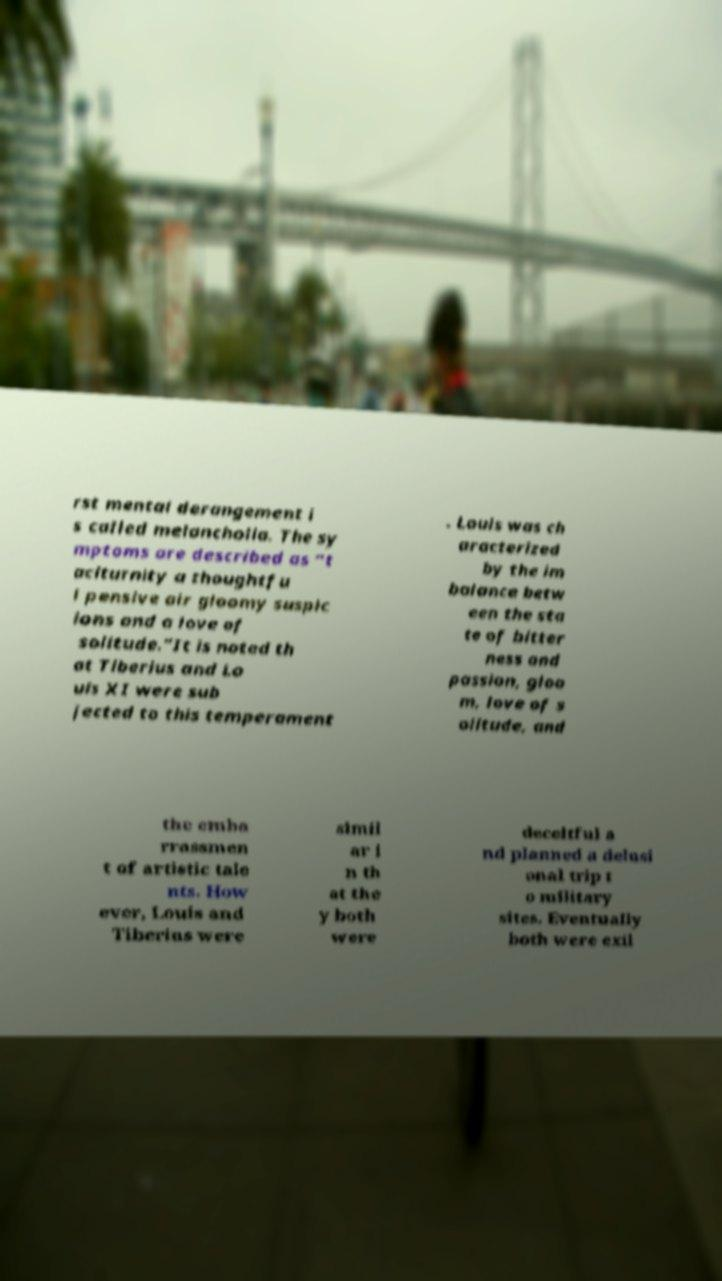Could you extract and type out the text from this image? rst mental derangement i s called melancholia. The sy mptoms are described as “t aciturnity a thoughtfu l pensive air gloomy suspic ions and a love of solitude.”It is noted th at Tiberius and Lo uis XI were sub jected to this temperament . Louis was ch aracterized by the im balance betw een the sta te of bitter ness and passion, gloo m, love of s olitude, and the emba rrassmen t of artistic tale nts. How ever, Louis and Tiberius were simil ar i n th at the y both were deceitful a nd planned a delusi onal trip t o military sites. Eventually both were exil 